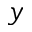<formula> <loc_0><loc_0><loc_500><loc_500>y</formula> 